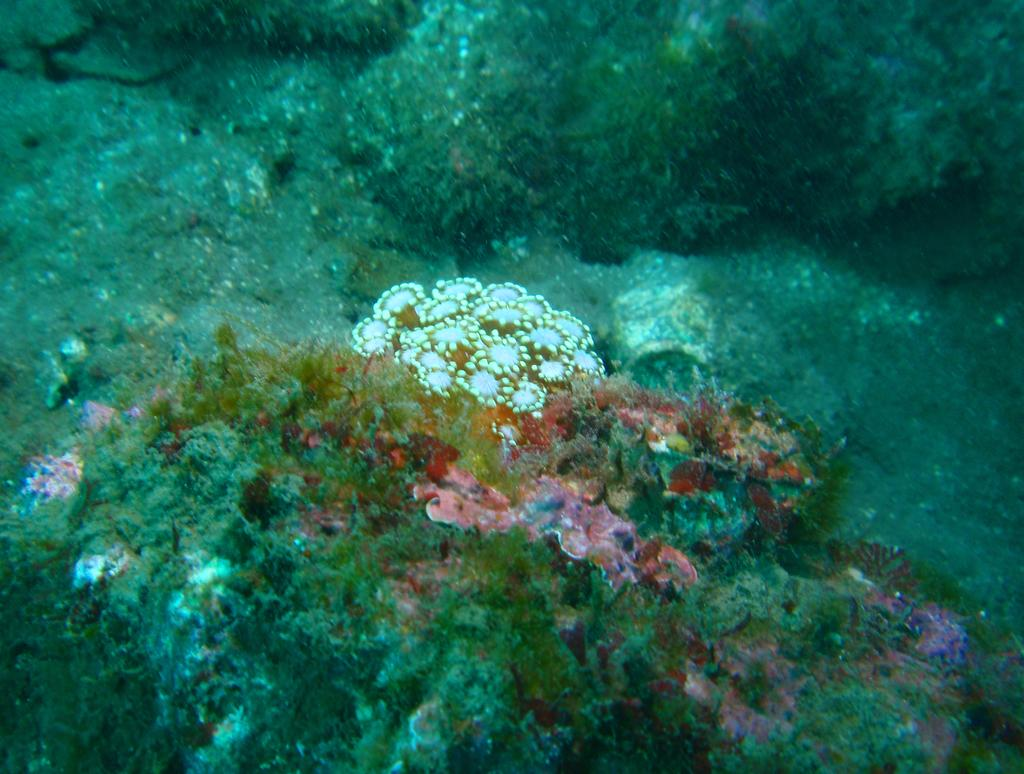What type of plants can be seen in the image? There are underwater plants in the image. What is the main focus of the image? There are flowers in the center of the image. Are there any other objects visible in the image besides the plants and flowers? Yes, there are other objects visible in the image. How does the division of labor affect the birthday celebration in the image? There is no mention of division of labor or a birthday celebration in the image, so it is not possible to answer that question. 